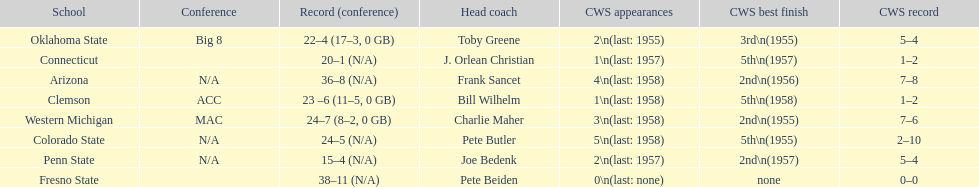Give me the full table as a dictionary. {'header': ['School', 'Conference', 'Record (conference)', 'Head coach', 'CWS appearances', 'CWS best finish', 'CWS record'], 'rows': [['Oklahoma State', 'Big 8', '22–4 (17–3, 0 GB)', 'Toby Greene', '2\\n(last: 1955)', '3rd\\n(1955)', '5–4'], ['Connecticut', '', '20–1 (N/A)', 'J. Orlean Christian', '1\\n(last: 1957)', '5th\\n(1957)', '1–2'], ['Arizona', 'N/A', '36–8 (N/A)', 'Frank Sancet', '4\\n(last: 1958)', '2nd\\n(1956)', '7–8'], ['Clemson', 'ACC', '23 –6 (11–5, 0 GB)', 'Bill Wilhelm', '1\\n(last: 1958)', '5th\\n(1958)', '1–2'], ['Western Michigan', 'MAC', '24–7 (8–2, 0 GB)', 'Charlie Maher', '3\\n(last: 1958)', '2nd\\n(1955)', '7–6'], ['Colorado State', 'N/A', '24–5 (N/A)', 'Pete Butler', '5\\n(last: 1958)', '5th\\n(1955)', '2–10'], ['Penn State', 'N/A', '15–4 (N/A)', 'Joe Bedenk', '2\\n(last: 1957)', '2nd\\n(1957)', '5–4'], ['Fresno State', '', '38–11 (N/A)', 'Pete Beiden', '0\\n(last: none)', 'none', '0–0']]} Which school has no cws appearances? Fresno State. 